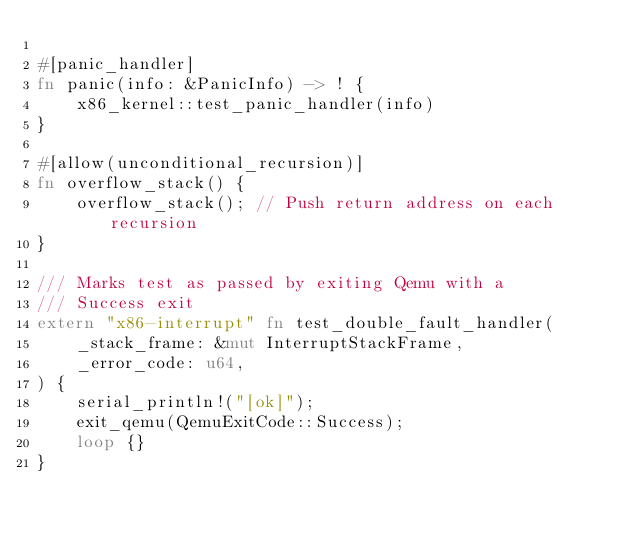<code> <loc_0><loc_0><loc_500><loc_500><_Rust_>
#[panic_handler]
fn panic(info: &PanicInfo) -> ! {
    x86_kernel::test_panic_handler(info)
}

#[allow(unconditional_recursion)]
fn overflow_stack() {
    overflow_stack(); // Push return address on each recursion
}

/// Marks test as passed by exiting Qemu with a
/// Success exit
extern "x86-interrupt" fn test_double_fault_handler(
    _stack_frame: &mut InterruptStackFrame,
    _error_code: u64,
) {
    serial_println!("[ok]");
    exit_qemu(QemuExitCode::Success);
    loop {}
}
</code> 